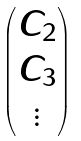<formula> <loc_0><loc_0><loc_500><loc_500>\begin{pmatrix} C _ { 2 } \\ C _ { 3 } \\ \vdots \end{pmatrix}</formula> 